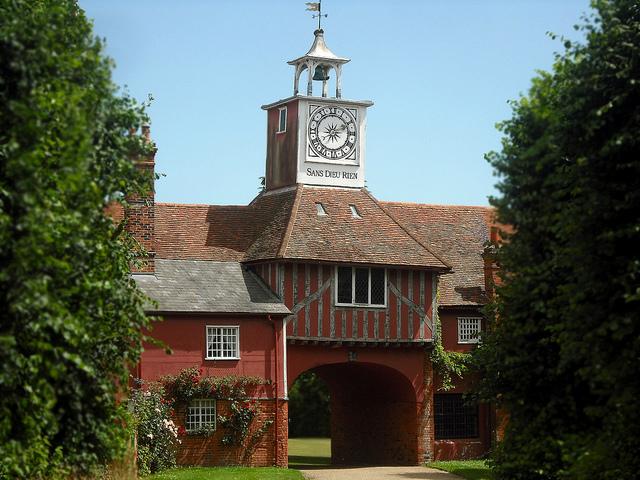Is this a large house?
Concise answer only. Yes. Is there a fountain in front of the building?
Write a very short answer. No. Is the sun shining?
Be succinct. Yes. What color is the building?
Short answer required. Red. Is this a church?
Quick response, please. No. What tree is on the left?
Short answer required. Shrub. Are there clouds visible?
Give a very brief answer. No. Is this a sunny day?
Answer briefly. Yes. What is the material right around the clock?
Concise answer only. Wood. What color are the flowers?
Answer briefly. Red. How many bells are there?
Answer briefly. 1. How tall is this building?
Keep it brief. 30 ft. What materials are on the roof?
Answer briefly. Shingles. How many clock faces does this building have?
Keep it brief. 1. Are the hedges well-groomed?
Keep it brief. No. Does the building in the back have an elevator?
Give a very brief answer. No. What is in gold at the top of the building?
Write a very short answer. Nothing. Do you a phone booth?
Give a very brief answer. No. What color is the clock tower in this photo?
Give a very brief answer. White. What are on both side of the building?
Give a very brief answer. Trees. What is around the tree?
Write a very short answer. Building. Are the buildings tall?
Keep it brief. Yes. How many flags are by the building's entrance?
Quick response, please. 0. Is the clock between two arches?
Keep it brief. No. Are there any entrance gates at the bottom of the tower?
Keep it brief. No. Is the building a high rise?
Concise answer only. No. Is part of this tower made of wood?
Concise answer only. Yes. Can the tree tell time?
Short answer required. No. How many windows are shown?
Give a very brief answer. 5. How many windows are pictured?
Answer briefly. 6. Is the emblem a sun face clock?
Concise answer only. Yes. 